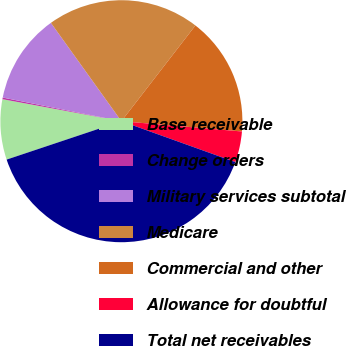Convert chart to OTSL. <chart><loc_0><loc_0><loc_500><loc_500><pie_chart><fcel>Base receivable<fcel>Change orders<fcel>Military services subtotal<fcel>Medicare<fcel>Commercial and other<fcel>Allowance for doubtful<fcel>Total net receivables<nl><fcel>8.05%<fcel>0.22%<fcel>11.97%<fcel>20.37%<fcel>15.88%<fcel>4.13%<fcel>39.38%<nl></chart> 